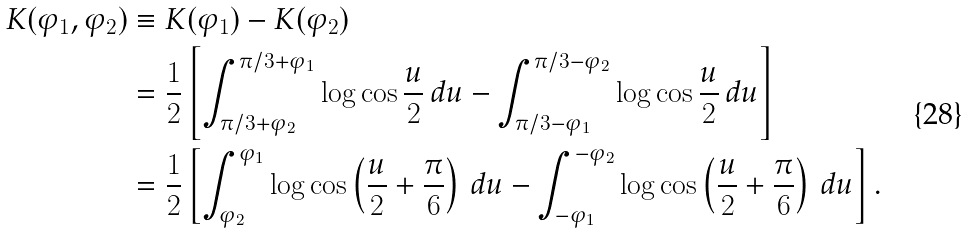Convert formula to latex. <formula><loc_0><loc_0><loc_500><loc_500>K ( \varphi _ { 1 } , \varphi _ { 2 } ) & \equiv K ( \varphi _ { 1 } ) - K ( \varphi _ { 2 } ) \\ & = \frac { 1 } { 2 } \left [ \int _ { \pi / 3 + \varphi _ { 2 } } ^ { \pi / 3 + \varphi _ { 1 } } \log \cos \frac { u } { 2 } \, d u - \int _ { \pi / 3 - \varphi _ { 1 } } ^ { \pi / 3 - \varphi _ { 2 } } \log \cos \frac { u } { 2 } \, d u \right ] \\ & = \frac { 1 } { 2 } \left [ \int _ { \varphi _ { 2 } } ^ { \varphi _ { 1 } } \log \cos \left ( \frac { u } { 2 } + \frac { \pi } { 6 } \right ) \, d u - \int _ { - \varphi _ { 1 } } ^ { - \varphi _ { 2 } } \log \cos \left ( \frac { u } { 2 } + \frac { \pi } { 6 } \right ) \, d u \right ] .</formula> 